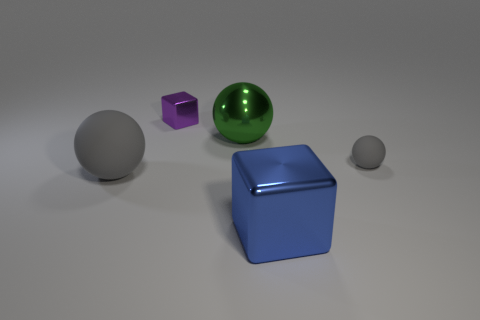Add 3 tiny shiny objects. How many objects exist? 8 Subtract all spheres. How many objects are left? 2 Subtract all purple objects. Subtract all purple things. How many objects are left? 3 Add 4 blue blocks. How many blue blocks are left? 5 Add 4 large gray matte spheres. How many large gray matte spheres exist? 5 Subtract 0 cyan balls. How many objects are left? 5 